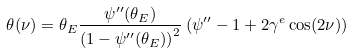Convert formula to latex. <formula><loc_0><loc_0><loc_500><loc_500>\theta ( \nu ) = \theta _ { E } \frac { \psi ^ { \prime \prime } ( \theta _ { E } ) } { \left ( 1 - \psi ^ { \prime \prime } ( \theta _ { E } ) \right ) ^ { 2 } } \left ( \psi ^ { \prime \prime } - 1 + 2 \gamma ^ { e } \cos ( 2 \nu ) \right )</formula> 